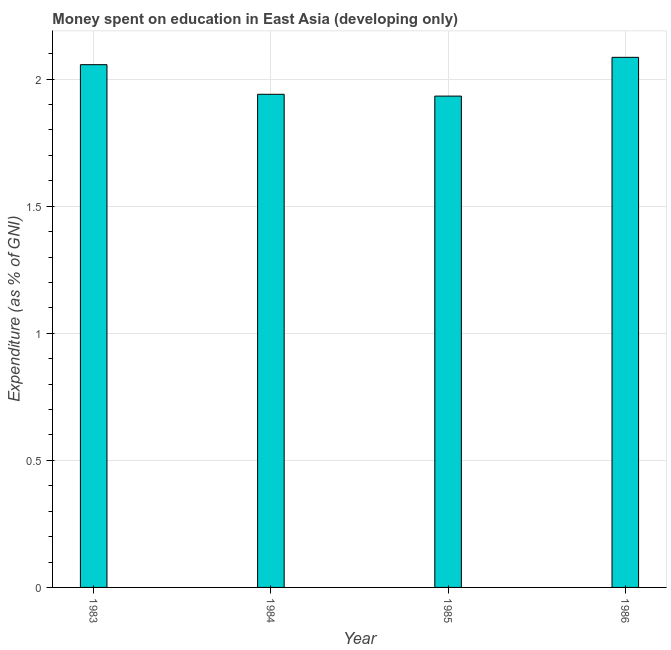Does the graph contain any zero values?
Offer a terse response. No. What is the title of the graph?
Keep it short and to the point. Money spent on education in East Asia (developing only). What is the label or title of the X-axis?
Your answer should be compact. Year. What is the label or title of the Y-axis?
Give a very brief answer. Expenditure (as % of GNI). What is the expenditure on education in 1984?
Your answer should be compact. 1.94. Across all years, what is the maximum expenditure on education?
Give a very brief answer. 2.09. Across all years, what is the minimum expenditure on education?
Make the answer very short. 1.93. In which year was the expenditure on education maximum?
Make the answer very short. 1986. In which year was the expenditure on education minimum?
Offer a terse response. 1985. What is the sum of the expenditure on education?
Keep it short and to the point. 8.02. What is the difference between the expenditure on education in 1983 and 1986?
Your answer should be compact. -0.03. What is the average expenditure on education per year?
Your answer should be very brief. 2. What is the median expenditure on education?
Offer a very short reply. 2. In how many years, is the expenditure on education greater than 0.6 %?
Your answer should be compact. 4. Do a majority of the years between 1984 and 1985 (inclusive) have expenditure on education greater than 0.7 %?
Offer a terse response. Yes. Is the difference between the expenditure on education in 1984 and 1985 greater than the difference between any two years?
Make the answer very short. No. What is the difference between the highest and the second highest expenditure on education?
Make the answer very short. 0.03. Is the sum of the expenditure on education in 1983 and 1986 greater than the maximum expenditure on education across all years?
Provide a succinct answer. Yes. How many bars are there?
Provide a succinct answer. 4. What is the difference between two consecutive major ticks on the Y-axis?
Offer a terse response. 0.5. Are the values on the major ticks of Y-axis written in scientific E-notation?
Keep it short and to the point. No. What is the Expenditure (as % of GNI) of 1983?
Provide a short and direct response. 2.06. What is the Expenditure (as % of GNI) of 1984?
Your response must be concise. 1.94. What is the Expenditure (as % of GNI) in 1985?
Provide a short and direct response. 1.93. What is the Expenditure (as % of GNI) in 1986?
Offer a terse response. 2.09. What is the difference between the Expenditure (as % of GNI) in 1983 and 1984?
Provide a short and direct response. 0.12. What is the difference between the Expenditure (as % of GNI) in 1983 and 1985?
Your answer should be very brief. 0.12. What is the difference between the Expenditure (as % of GNI) in 1983 and 1986?
Give a very brief answer. -0.03. What is the difference between the Expenditure (as % of GNI) in 1984 and 1985?
Provide a succinct answer. 0.01. What is the difference between the Expenditure (as % of GNI) in 1984 and 1986?
Offer a terse response. -0.15. What is the difference between the Expenditure (as % of GNI) in 1985 and 1986?
Make the answer very short. -0.15. What is the ratio of the Expenditure (as % of GNI) in 1983 to that in 1984?
Offer a terse response. 1.06. What is the ratio of the Expenditure (as % of GNI) in 1983 to that in 1985?
Keep it short and to the point. 1.06. What is the ratio of the Expenditure (as % of GNI) in 1983 to that in 1986?
Offer a very short reply. 0.99. What is the ratio of the Expenditure (as % of GNI) in 1985 to that in 1986?
Offer a terse response. 0.93. 